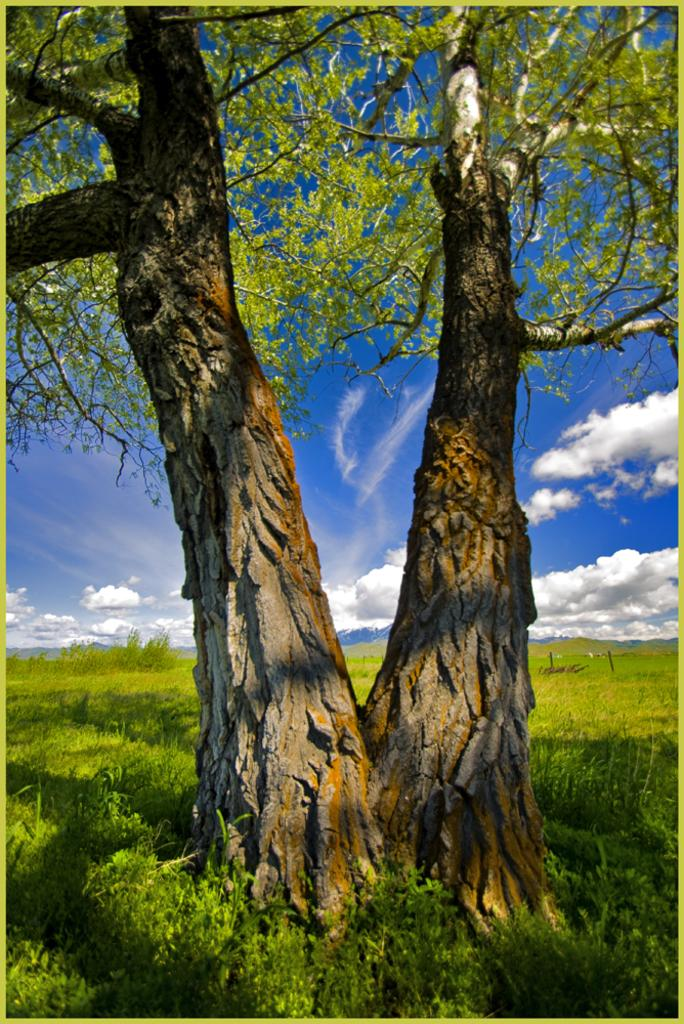What type of vegetation is present on the ground in the image? There is grass on the ground in the image. What other natural elements can be seen in the image? There are trees in the image. What else is visible in the image besides the vegetation? There are objects in the image. How would you describe the sky in the image? The sky is cloudy in the image. What type of liquid can be seen flowing from the wrench in the image? There is no wrench or liquid present in the image. 